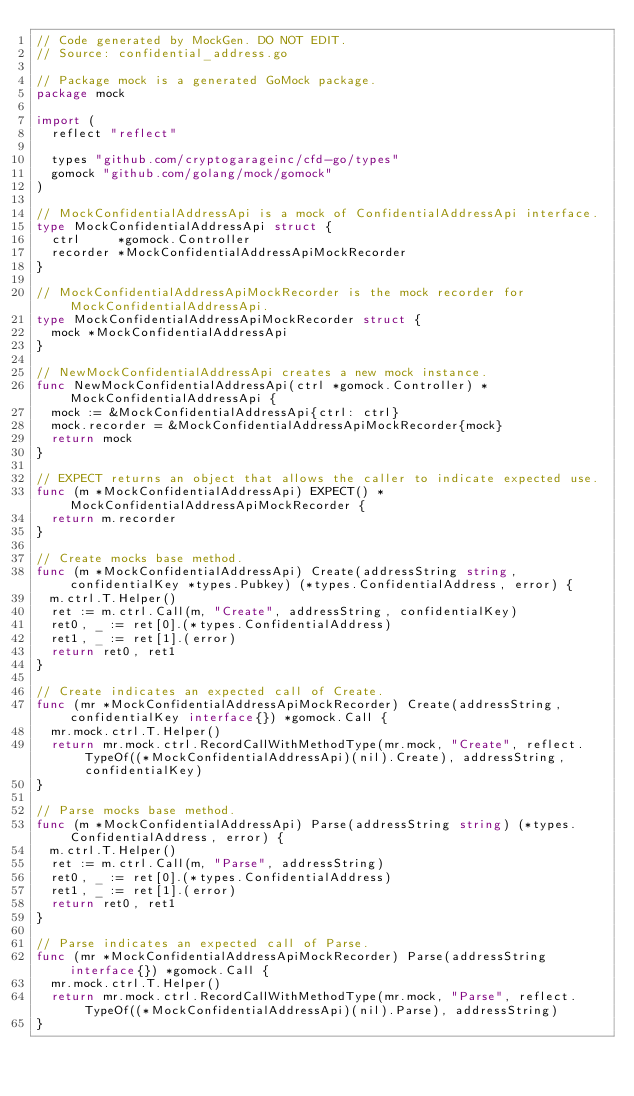<code> <loc_0><loc_0><loc_500><loc_500><_Go_>// Code generated by MockGen. DO NOT EDIT.
// Source: confidential_address.go

// Package mock is a generated GoMock package.
package mock

import (
	reflect "reflect"

	types "github.com/cryptogarageinc/cfd-go/types"
	gomock "github.com/golang/mock/gomock"
)

// MockConfidentialAddressApi is a mock of ConfidentialAddressApi interface.
type MockConfidentialAddressApi struct {
	ctrl     *gomock.Controller
	recorder *MockConfidentialAddressApiMockRecorder
}

// MockConfidentialAddressApiMockRecorder is the mock recorder for MockConfidentialAddressApi.
type MockConfidentialAddressApiMockRecorder struct {
	mock *MockConfidentialAddressApi
}

// NewMockConfidentialAddressApi creates a new mock instance.
func NewMockConfidentialAddressApi(ctrl *gomock.Controller) *MockConfidentialAddressApi {
	mock := &MockConfidentialAddressApi{ctrl: ctrl}
	mock.recorder = &MockConfidentialAddressApiMockRecorder{mock}
	return mock
}

// EXPECT returns an object that allows the caller to indicate expected use.
func (m *MockConfidentialAddressApi) EXPECT() *MockConfidentialAddressApiMockRecorder {
	return m.recorder
}

// Create mocks base method.
func (m *MockConfidentialAddressApi) Create(addressString string, confidentialKey *types.Pubkey) (*types.ConfidentialAddress, error) {
	m.ctrl.T.Helper()
	ret := m.ctrl.Call(m, "Create", addressString, confidentialKey)
	ret0, _ := ret[0].(*types.ConfidentialAddress)
	ret1, _ := ret[1].(error)
	return ret0, ret1
}

// Create indicates an expected call of Create.
func (mr *MockConfidentialAddressApiMockRecorder) Create(addressString, confidentialKey interface{}) *gomock.Call {
	mr.mock.ctrl.T.Helper()
	return mr.mock.ctrl.RecordCallWithMethodType(mr.mock, "Create", reflect.TypeOf((*MockConfidentialAddressApi)(nil).Create), addressString, confidentialKey)
}

// Parse mocks base method.
func (m *MockConfidentialAddressApi) Parse(addressString string) (*types.ConfidentialAddress, error) {
	m.ctrl.T.Helper()
	ret := m.ctrl.Call(m, "Parse", addressString)
	ret0, _ := ret[0].(*types.ConfidentialAddress)
	ret1, _ := ret[1].(error)
	return ret0, ret1
}

// Parse indicates an expected call of Parse.
func (mr *MockConfidentialAddressApiMockRecorder) Parse(addressString interface{}) *gomock.Call {
	mr.mock.ctrl.T.Helper()
	return mr.mock.ctrl.RecordCallWithMethodType(mr.mock, "Parse", reflect.TypeOf((*MockConfidentialAddressApi)(nil).Parse), addressString)
}
</code> 